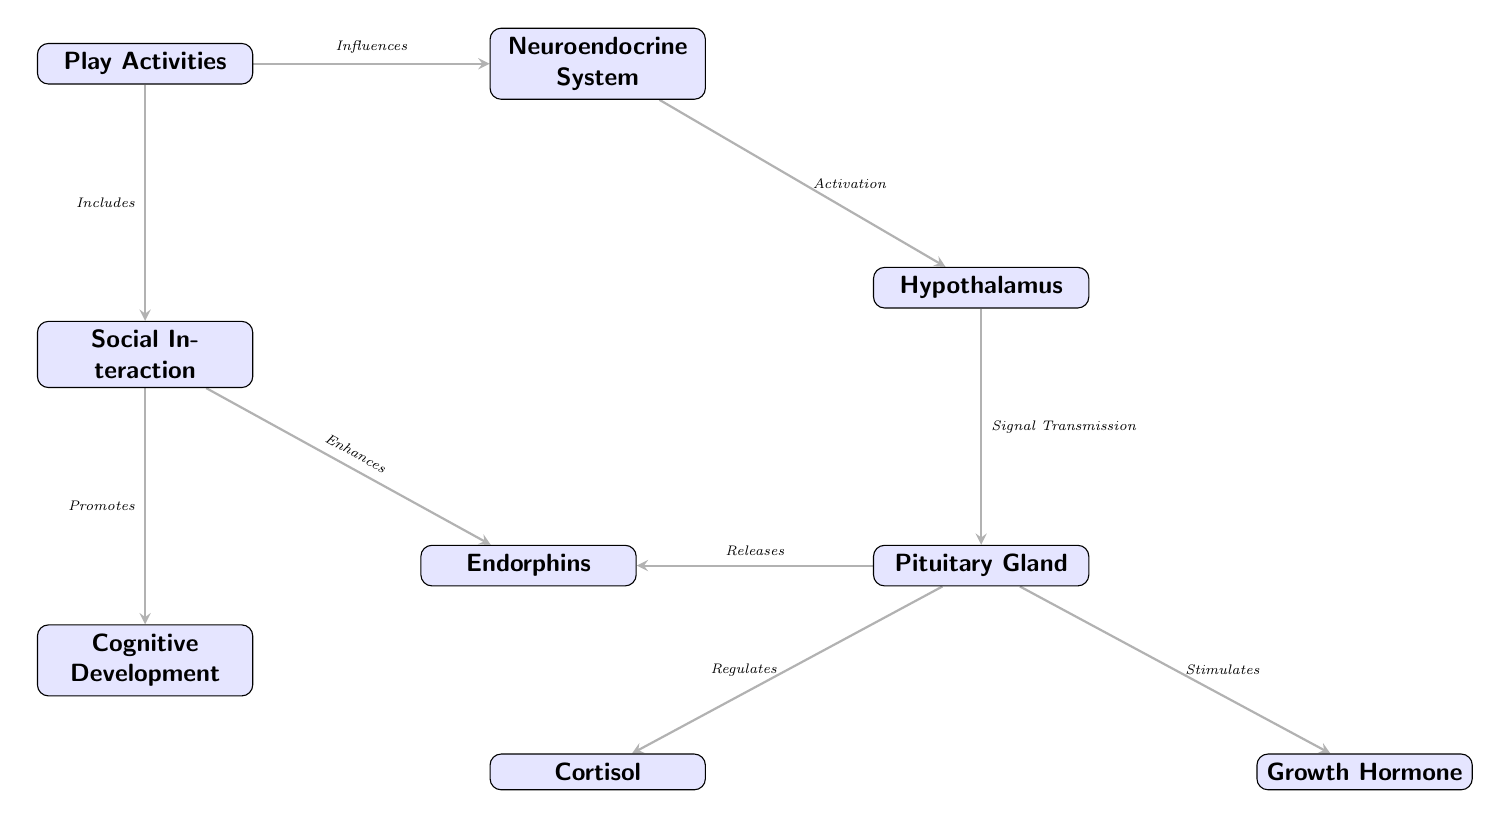What influences the neuroendocrine system? The diagram clearly indicates that 'Play Activities' influences the 'Neuroendocrine System,' as denoted by the arrow between the two nodes.
Answer: Play Activities Which gland is regulated by the pituitary gland? The diagram shows an arrow pointing from the pituitary gland to 'Cortisol,' indicating that the pituitary gland regulates cortisol.
Answer: Cortisol How many nodes are in the diagram? By counting all the distinct boxes in the diagram, we find a total of 8 nodes connected by edges.
Answer: 8 What does social interaction enhance? The diagram features an arrow going from 'Social Interaction' to 'Endorphins,' indicating that social interaction enhances endorphins.
Answer: Endorphins What does the pituitary gland release? The diagram illustrates that the pituitary gland releases 'Endorphins,' signified by the arrow pointing from the pituitary gland to the endorphins node.
Answer: Endorphins How does play affect cognitive development? The diagram states that 'Play Activities' promotes 'Cognitive Development' through a direct connection, as shown by the arrow from 'Play Activities' to 'Cognitive Development.'
Answer: Promotes What is the relationship between the hypothalamus and the pituitary gland? The flow of information shows that the hypothalamus sends a signal to the pituitary gland based on the arrow pointing from the hypothalamus to the pituitary gland.
Answer: Signal Transmission Which hormone is stimulated by the pituitary gland? The diagram shows an arrow from the pituitary gland to 'Growth Hormone,' indicating that the pituitary gland stimulates the growth hormone.
Answer: Growth Hormone 